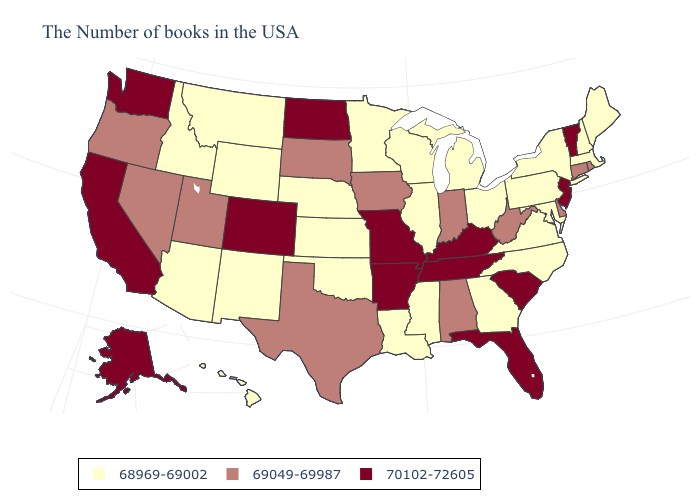What is the value of New Jersey?
Concise answer only. 70102-72605. Name the states that have a value in the range 69049-69987?
Be succinct. Rhode Island, Connecticut, Delaware, West Virginia, Indiana, Alabama, Iowa, Texas, South Dakota, Utah, Nevada, Oregon. What is the value of Kansas?
Short answer required. 68969-69002. Does Missouri have the lowest value in the MidWest?
Quick response, please. No. What is the value of South Dakota?
Write a very short answer. 69049-69987. What is the value of Utah?
Keep it brief. 69049-69987. Among the states that border Connecticut , does Massachusetts have the lowest value?
Concise answer only. Yes. Name the states that have a value in the range 68969-69002?
Write a very short answer. Maine, Massachusetts, New Hampshire, New York, Maryland, Pennsylvania, Virginia, North Carolina, Ohio, Georgia, Michigan, Wisconsin, Illinois, Mississippi, Louisiana, Minnesota, Kansas, Nebraska, Oklahoma, Wyoming, New Mexico, Montana, Arizona, Idaho, Hawaii. Which states have the lowest value in the USA?
Write a very short answer. Maine, Massachusetts, New Hampshire, New York, Maryland, Pennsylvania, Virginia, North Carolina, Ohio, Georgia, Michigan, Wisconsin, Illinois, Mississippi, Louisiana, Minnesota, Kansas, Nebraska, Oklahoma, Wyoming, New Mexico, Montana, Arizona, Idaho, Hawaii. What is the value of New Mexico?
Give a very brief answer. 68969-69002. What is the highest value in the USA?
Short answer required. 70102-72605. Name the states that have a value in the range 69049-69987?
Concise answer only. Rhode Island, Connecticut, Delaware, West Virginia, Indiana, Alabama, Iowa, Texas, South Dakota, Utah, Nevada, Oregon. What is the value of Washington?
Answer briefly. 70102-72605. Does the map have missing data?
Answer briefly. No. Which states have the lowest value in the USA?
Answer briefly. Maine, Massachusetts, New Hampshire, New York, Maryland, Pennsylvania, Virginia, North Carolina, Ohio, Georgia, Michigan, Wisconsin, Illinois, Mississippi, Louisiana, Minnesota, Kansas, Nebraska, Oklahoma, Wyoming, New Mexico, Montana, Arizona, Idaho, Hawaii. 